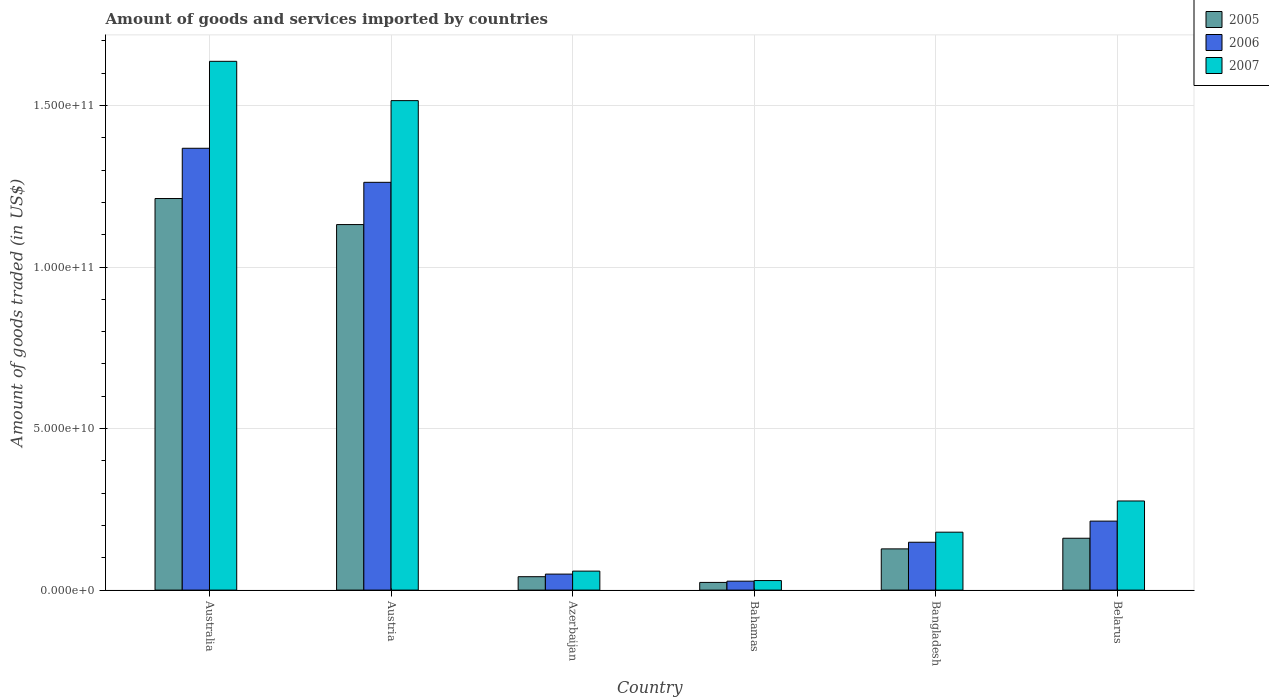How many different coloured bars are there?
Your answer should be compact. 3. How many bars are there on the 6th tick from the left?
Your answer should be compact. 3. How many bars are there on the 4th tick from the right?
Your answer should be compact. 3. What is the label of the 6th group of bars from the left?
Offer a terse response. Belarus. What is the total amount of goods and services imported in 2007 in Belarus?
Provide a succinct answer. 2.76e+1. Across all countries, what is the maximum total amount of goods and services imported in 2007?
Provide a succinct answer. 1.64e+11. Across all countries, what is the minimum total amount of goods and services imported in 2005?
Provide a succinct answer. 2.38e+09. In which country was the total amount of goods and services imported in 2005 maximum?
Offer a terse response. Australia. In which country was the total amount of goods and services imported in 2006 minimum?
Offer a very short reply. Bahamas. What is the total total amount of goods and services imported in 2005 in the graph?
Your answer should be very brief. 2.70e+11. What is the difference between the total amount of goods and services imported in 2006 in Austria and that in Azerbaijan?
Your answer should be very brief. 1.21e+11. What is the difference between the total amount of goods and services imported in 2006 in Bangladesh and the total amount of goods and services imported in 2007 in Austria?
Provide a short and direct response. -1.37e+11. What is the average total amount of goods and services imported in 2006 per country?
Provide a short and direct response. 5.11e+1. What is the difference between the total amount of goods and services imported of/in 2006 and total amount of goods and services imported of/in 2005 in Belarus?
Provide a succinct answer. 5.30e+09. What is the ratio of the total amount of goods and services imported in 2007 in Bahamas to that in Belarus?
Provide a succinct answer. 0.11. Is the difference between the total amount of goods and services imported in 2006 in Austria and Bahamas greater than the difference between the total amount of goods and services imported in 2005 in Austria and Bahamas?
Offer a very short reply. Yes. What is the difference between the highest and the second highest total amount of goods and services imported in 2006?
Keep it short and to the point. 1.05e+1. What is the difference between the highest and the lowest total amount of goods and services imported in 2006?
Your answer should be very brief. 1.34e+11. Is the sum of the total amount of goods and services imported in 2006 in Australia and Azerbaijan greater than the maximum total amount of goods and services imported in 2007 across all countries?
Provide a succinct answer. No. What does the 1st bar from the left in Bahamas represents?
Provide a succinct answer. 2005. What does the 3rd bar from the right in Belarus represents?
Provide a short and direct response. 2005. Is it the case that in every country, the sum of the total amount of goods and services imported in 2007 and total amount of goods and services imported in 2006 is greater than the total amount of goods and services imported in 2005?
Provide a succinct answer. Yes. How many bars are there?
Offer a terse response. 18. Are all the bars in the graph horizontal?
Give a very brief answer. No. Does the graph contain any zero values?
Give a very brief answer. No. Does the graph contain grids?
Ensure brevity in your answer.  Yes. Where does the legend appear in the graph?
Your response must be concise. Top right. How are the legend labels stacked?
Your answer should be very brief. Vertical. What is the title of the graph?
Your answer should be very brief. Amount of goods and services imported by countries. Does "2008" appear as one of the legend labels in the graph?
Offer a very short reply. No. What is the label or title of the X-axis?
Your response must be concise. Country. What is the label or title of the Y-axis?
Give a very brief answer. Amount of goods traded (in US$). What is the Amount of goods traded (in US$) of 2005 in Australia?
Offer a very short reply. 1.21e+11. What is the Amount of goods traded (in US$) in 2006 in Australia?
Your answer should be compact. 1.37e+11. What is the Amount of goods traded (in US$) in 2007 in Australia?
Ensure brevity in your answer.  1.64e+11. What is the Amount of goods traded (in US$) of 2005 in Austria?
Provide a short and direct response. 1.13e+11. What is the Amount of goods traded (in US$) in 2006 in Austria?
Offer a terse response. 1.26e+11. What is the Amount of goods traded (in US$) of 2007 in Austria?
Ensure brevity in your answer.  1.52e+11. What is the Amount of goods traded (in US$) in 2005 in Azerbaijan?
Offer a very short reply. 4.15e+09. What is the Amount of goods traded (in US$) of 2006 in Azerbaijan?
Your answer should be very brief. 4.95e+09. What is the Amount of goods traded (in US$) of 2007 in Azerbaijan?
Provide a short and direct response. 5.88e+09. What is the Amount of goods traded (in US$) in 2005 in Bahamas?
Make the answer very short. 2.38e+09. What is the Amount of goods traded (in US$) in 2006 in Bahamas?
Provide a short and direct response. 2.77e+09. What is the Amount of goods traded (in US$) of 2007 in Bahamas?
Your response must be concise. 2.96e+09. What is the Amount of goods traded (in US$) of 2005 in Bangladesh?
Ensure brevity in your answer.  1.28e+1. What is the Amount of goods traded (in US$) in 2006 in Bangladesh?
Provide a succinct answer. 1.48e+1. What is the Amount of goods traded (in US$) of 2007 in Bangladesh?
Provide a succinct answer. 1.79e+1. What is the Amount of goods traded (in US$) of 2005 in Belarus?
Provide a short and direct response. 1.61e+1. What is the Amount of goods traded (in US$) in 2006 in Belarus?
Keep it short and to the point. 2.14e+1. What is the Amount of goods traded (in US$) of 2007 in Belarus?
Provide a short and direct response. 2.76e+1. Across all countries, what is the maximum Amount of goods traded (in US$) of 2005?
Provide a short and direct response. 1.21e+11. Across all countries, what is the maximum Amount of goods traded (in US$) in 2006?
Provide a short and direct response. 1.37e+11. Across all countries, what is the maximum Amount of goods traded (in US$) of 2007?
Your response must be concise. 1.64e+11. Across all countries, what is the minimum Amount of goods traded (in US$) in 2005?
Provide a succinct answer. 2.38e+09. Across all countries, what is the minimum Amount of goods traded (in US$) in 2006?
Offer a very short reply. 2.77e+09. Across all countries, what is the minimum Amount of goods traded (in US$) of 2007?
Give a very brief answer. 2.96e+09. What is the total Amount of goods traded (in US$) in 2005 in the graph?
Give a very brief answer. 2.70e+11. What is the total Amount of goods traded (in US$) in 2006 in the graph?
Your answer should be compact. 3.07e+11. What is the total Amount of goods traded (in US$) of 2007 in the graph?
Offer a terse response. 3.70e+11. What is the difference between the Amount of goods traded (in US$) in 2005 in Australia and that in Austria?
Offer a very short reply. 8.06e+09. What is the difference between the Amount of goods traded (in US$) of 2006 in Australia and that in Austria?
Your answer should be compact. 1.05e+1. What is the difference between the Amount of goods traded (in US$) of 2007 in Australia and that in Austria?
Provide a short and direct response. 1.22e+1. What is the difference between the Amount of goods traded (in US$) in 2005 in Australia and that in Azerbaijan?
Your response must be concise. 1.17e+11. What is the difference between the Amount of goods traded (in US$) in 2006 in Australia and that in Azerbaijan?
Provide a succinct answer. 1.32e+11. What is the difference between the Amount of goods traded (in US$) in 2007 in Australia and that in Azerbaijan?
Offer a very short reply. 1.58e+11. What is the difference between the Amount of goods traded (in US$) of 2005 in Australia and that in Bahamas?
Offer a terse response. 1.19e+11. What is the difference between the Amount of goods traded (in US$) in 2006 in Australia and that in Bahamas?
Offer a terse response. 1.34e+11. What is the difference between the Amount of goods traded (in US$) of 2007 in Australia and that in Bahamas?
Provide a succinct answer. 1.61e+11. What is the difference between the Amount of goods traded (in US$) of 2005 in Australia and that in Bangladesh?
Your answer should be compact. 1.08e+11. What is the difference between the Amount of goods traded (in US$) of 2006 in Australia and that in Bangladesh?
Keep it short and to the point. 1.22e+11. What is the difference between the Amount of goods traded (in US$) of 2007 in Australia and that in Bangladesh?
Make the answer very short. 1.46e+11. What is the difference between the Amount of goods traded (in US$) in 2005 in Australia and that in Belarus?
Your answer should be compact. 1.05e+11. What is the difference between the Amount of goods traded (in US$) of 2006 in Australia and that in Belarus?
Make the answer very short. 1.15e+11. What is the difference between the Amount of goods traded (in US$) of 2007 in Australia and that in Belarus?
Ensure brevity in your answer.  1.36e+11. What is the difference between the Amount of goods traded (in US$) of 2005 in Austria and that in Azerbaijan?
Ensure brevity in your answer.  1.09e+11. What is the difference between the Amount of goods traded (in US$) of 2006 in Austria and that in Azerbaijan?
Offer a very short reply. 1.21e+11. What is the difference between the Amount of goods traded (in US$) in 2007 in Austria and that in Azerbaijan?
Give a very brief answer. 1.46e+11. What is the difference between the Amount of goods traded (in US$) of 2005 in Austria and that in Bahamas?
Keep it short and to the point. 1.11e+11. What is the difference between the Amount of goods traded (in US$) in 2006 in Austria and that in Bahamas?
Provide a short and direct response. 1.23e+11. What is the difference between the Amount of goods traded (in US$) in 2007 in Austria and that in Bahamas?
Offer a terse response. 1.49e+11. What is the difference between the Amount of goods traded (in US$) of 2005 in Austria and that in Bangladesh?
Give a very brief answer. 1.00e+11. What is the difference between the Amount of goods traded (in US$) in 2006 in Austria and that in Bangladesh?
Offer a very short reply. 1.11e+11. What is the difference between the Amount of goods traded (in US$) of 2007 in Austria and that in Bangladesh?
Give a very brief answer. 1.34e+11. What is the difference between the Amount of goods traded (in US$) in 2005 in Austria and that in Belarus?
Keep it short and to the point. 9.71e+1. What is the difference between the Amount of goods traded (in US$) of 2006 in Austria and that in Belarus?
Provide a short and direct response. 1.05e+11. What is the difference between the Amount of goods traded (in US$) in 2007 in Austria and that in Belarus?
Make the answer very short. 1.24e+11. What is the difference between the Amount of goods traded (in US$) of 2005 in Azerbaijan and that in Bahamas?
Keep it short and to the point. 1.77e+09. What is the difference between the Amount of goods traded (in US$) of 2006 in Azerbaijan and that in Bahamas?
Your response must be concise. 2.19e+09. What is the difference between the Amount of goods traded (in US$) in 2007 in Azerbaijan and that in Bahamas?
Provide a succinct answer. 2.92e+09. What is the difference between the Amount of goods traded (in US$) in 2005 in Azerbaijan and that in Bangladesh?
Your response must be concise. -8.61e+09. What is the difference between the Amount of goods traded (in US$) of 2006 in Azerbaijan and that in Bangladesh?
Your answer should be compact. -9.86e+09. What is the difference between the Amount of goods traded (in US$) in 2007 in Azerbaijan and that in Bangladesh?
Provide a succinct answer. -1.20e+1. What is the difference between the Amount of goods traded (in US$) in 2005 in Azerbaijan and that in Belarus?
Make the answer very short. -1.19e+1. What is the difference between the Amount of goods traded (in US$) in 2006 in Azerbaijan and that in Belarus?
Offer a terse response. -1.64e+1. What is the difference between the Amount of goods traded (in US$) in 2007 in Azerbaijan and that in Belarus?
Your response must be concise. -2.17e+1. What is the difference between the Amount of goods traded (in US$) in 2005 in Bahamas and that in Bangladesh?
Give a very brief answer. -1.04e+1. What is the difference between the Amount of goods traded (in US$) in 2006 in Bahamas and that in Bangladesh?
Provide a succinct answer. -1.20e+1. What is the difference between the Amount of goods traded (in US$) in 2007 in Bahamas and that in Bangladesh?
Provide a succinct answer. -1.50e+1. What is the difference between the Amount of goods traded (in US$) of 2005 in Bahamas and that in Belarus?
Provide a short and direct response. -1.37e+1. What is the difference between the Amount of goods traded (in US$) of 2006 in Bahamas and that in Belarus?
Your response must be concise. -1.86e+1. What is the difference between the Amount of goods traded (in US$) in 2007 in Bahamas and that in Belarus?
Ensure brevity in your answer.  -2.46e+1. What is the difference between the Amount of goods traded (in US$) in 2005 in Bangladesh and that in Belarus?
Offer a very short reply. -3.30e+09. What is the difference between the Amount of goods traded (in US$) of 2006 in Bangladesh and that in Belarus?
Offer a terse response. -6.54e+09. What is the difference between the Amount of goods traded (in US$) in 2007 in Bangladesh and that in Belarus?
Offer a very short reply. -9.66e+09. What is the difference between the Amount of goods traded (in US$) of 2005 in Australia and the Amount of goods traded (in US$) of 2006 in Austria?
Keep it short and to the point. -5.01e+09. What is the difference between the Amount of goods traded (in US$) of 2005 in Australia and the Amount of goods traded (in US$) of 2007 in Austria?
Offer a very short reply. -3.03e+1. What is the difference between the Amount of goods traded (in US$) in 2006 in Australia and the Amount of goods traded (in US$) in 2007 in Austria?
Your response must be concise. -1.47e+1. What is the difference between the Amount of goods traded (in US$) of 2005 in Australia and the Amount of goods traded (in US$) of 2006 in Azerbaijan?
Ensure brevity in your answer.  1.16e+11. What is the difference between the Amount of goods traded (in US$) in 2005 in Australia and the Amount of goods traded (in US$) in 2007 in Azerbaijan?
Offer a terse response. 1.15e+11. What is the difference between the Amount of goods traded (in US$) in 2006 in Australia and the Amount of goods traded (in US$) in 2007 in Azerbaijan?
Make the answer very short. 1.31e+11. What is the difference between the Amount of goods traded (in US$) in 2005 in Australia and the Amount of goods traded (in US$) in 2006 in Bahamas?
Your answer should be compact. 1.18e+11. What is the difference between the Amount of goods traded (in US$) of 2005 in Australia and the Amount of goods traded (in US$) of 2007 in Bahamas?
Offer a terse response. 1.18e+11. What is the difference between the Amount of goods traded (in US$) in 2006 in Australia and the Amount of goods traded (in US$) in 2007 in Bahamas?
Give a very brief answer. 1.34e+11. What is the difference between the Amount of goods traded (in US$) in 2005 in Australia and the Amount of goods traded (in US$) in 2006 in Bangladesh?
Ensure brevity in your answer.  1.06e+11. What is the difference between the Amount of goods traded (in US$) of 2005 in Australia and the Amount of goods traded (in US$) of 2007 in Bangladesh?
Offer a terse response. 1.03e+11. What is the difference between the Amount of goods traded (in US$) of 2006 in Australia and the Amount of goods traded (in US$) of 2007 in Bangladesh?
Your answer should be very brief. 1.19e+11. What is the difference between the Amount of goods traded (in US$) of 2005 in Australia and the Amount of goods traded (in US$) of 2006 in Belarus?
Make the answer very short. 9.99e+1. What is the difference between the Amount of goods traded (in US$) of 2005 in Australia and the Amount of goods traded (in US$) of 2007 in Belarus?
Your answer should be very brief. 9.36e+1. What is the difference between the Amount of goods traded (in US$) in 2006 in Australia and the Amount of goods traded (in US$) in 2007 in Belarus?
Provide a short and direct response. 1.09e+11. What is the difference between the Amount of goods traded (in US$) of 2005 in Austria and the Amount of goods traded (in US$) of 2006 in Azerbaijan?
Provide a short and direct response. 1.08e+11. What is the difference between the Amount of goods traded (in US$) in 2005 in Austria and the Amount of goods traded (in US$) in 2007 in Azerbaijan?
Offer a very short reply. 1.07e+11. What is the difference between the Amount of goods traded (in US$) of 2006 in Austria and the Amount of goods traded (in US$) of 2007 in Azerbaijan?
Ensure brevity in your answer.  1.20e+11. What is the difference between the Amount of goods traded (in US$) of 2005 in Austria and the Amount of goods traded (in US$) of 2006 in Bahamas?
Provide a succinct answer. 1.10e+11. What is the difference between the Amount of goods traded (in US$) of 2005 in Austria and the Amount of goods traded (in US$) of 2007 in Bahamas?
Your response must be concise. 1.10e+11. What is the difference between the Amount of goods traded (in US$) of 2006 in Austria and the Amount of goods traded (in US$) of 2007 in Bahamas?
Ensure brevity in your answer.  1.23e+11. What is the difference between the Amount of goods traded (in US$) of 2005 in Austria and the Amount of goods traded (in US$) of 2006 in Bangladesh?
Your answer should be very brief. 9.83e+1. What is the difference between the Amount of goods traded (in US$) in 2005 in Austria and the Amount of goods traded (in US$) in 2007 in Bangladesh?
Your response must be concise. 9.52e+1. What is the difference between the Amount of goods traded (in US$) in 2006 in Austria and the Amount of goods traded (in US$) in 2007 in Bangladesh?
Give a very brief answer. 1.08e+11. What is the difference between the Amount of goods traded (in US$) in 2005 in Austria and the Amount of goods traded (in US$) in 2006 in Belarus?
Your answer should be compact. 9.18e+1. What is the difference between the Amount of goods traded (in US$) of 2005 in Austria and the Amount of goods traded (in US$) of 2007 in Belarus?
Provide a short and direct response. 8.56e+1. What is the difference between the Amount of goods traded (in US$) of 2006 in Austria and the Amount of goods traded (in US$) of 2007 in Belarus?
Offer a terse response. 9.86e+1. What is the difference between the Amount of goods traded (in US$) of 2005 in Azerbaijan and the Amount of goods traded (in US$) of 2006 in Bahamas?
Offer a very short reply. 1.39e+09. What is the difference between the Amount of goods traded (in US$) in 2005 in Azerbaijan and the Amount of goods traded (in US$) in 2007 in Bahamas?
Ensure brevity in your answer.  1.19e+09. What is the difference between the Amount of goods traded (in US$) of 2006 in Azerbaijan and the Amount of goods traded (in US$) of 2007 in Bahamas?
Your answer should be compact. 2.00e+09. What is the difference between the Amount of goods traded (in US$) of 2005 in Azerbaijan and the Amount of goods traded (in US$) of 2006 in Bangladesh?
Your answer should be compact. -1.07e+1. What is the difference between the Amount of goods traded (in US$) in 2005 in Azerbaijan and the Amount of goods traded (in US$) in 2007 in Bangladesh?
Offer a terse response. -1.38e+1. What is the difference between the Amount of goods traded (in US$) in 2006 in Azerbaijan and the Amount of goods traded (in US$) in 2007 in Bangladesh?
Your answer should be very brief. -1.30e+1. What is the difference between the Amount of goods traded (in US$) in 2005 in Azerbaijan and the Amount of goods traded (in US$) in 2006 in Belarus?
Provide a succinct answer. -1.72e+1. What is the difference between the Amount of goods traded (in US$) of 2005 in Azerbaijan and the Amount of goods traded (in US$) of 2007 in Belarus?
Provide a short and direct response. -2.34e+1. What is the difference between the Amount of goods traded (in US$) in 2006 in Azerbaijan and the Amount of goods traded (in US$) in 2007 in Belarus?
Your answer should be very brief. -2.26e+1. What is the difference between the Amount of goods traded (in US$) in 2005 in Bahamas and the Amount of goods traded (in US$) in 2006 in Bangladesh?
Make the answer very short. -1.24e+1. What is the difference between the Amount of goods traded (in US$) of 2005 in Bahamas and the Amount of goods traded (in US$) of 2007 in Bangladesh?
Provide a succinct answer. -1.55e+1. What is the difference between the Amount of goods traded (in US$) of 2006 in Bahamas and the Amount of goods traded (in US$) of 2007 in Bangladesh?
Give a very brief answer. -1.52e+1. What is the difference between the Amount of goods traded (in US$) in 2005 in Bahamas and the Amount of goods traded (in US$) in 2006 in Belarus?
Ensure brevity in your answer.  -1.90e+1. What is the difference between the Amount of goods traded (in US$) of 2005 in Bahamas and the Amount of goods traded (in US$) of 2007 in Belarus?
Your answer should be very brief. -2.52e+1. What is the difference between the Amount of goods traded (in US$) in 2006 in Bahamas and the Amount of goods traded (in US$) in 2007 in Belarus?
Your answer should be compact. -2.48e+1. What is the difference between the Amount of goods traded (in US$) of 2005 in Bangladesh and the Amount of goods traded (in US$) of 2006 in Belarus?
Keep it short and to the point. -8.59e+09. What is the difference between the Amount of goods traded (in US$) of 2005 in Bangladesh and the Amount of goods traded (in US$) of 2007 in Belarus?
Make the answer very short. -1.48e+1. What is the difference between the Amount of goods traded (in US$) in 2006 in Bangladesh and the Amount of goods traded (in US$) in 2007 in Belarus?
Your response must be concise. -1.28e+1. What is the average Amount of goods traded (in US$) in 2005 per country?
Keep it short and to the point. 4.49e+1. What is the average Amount of goods traded (in US$) of 2006 per country?
Give a very brief answer. 5.11e+1. What is the average Amount of goods traded (in US$) of 2007 per country?
Offer a terse response. 6.16e+1. What is the difference between the Amount of goods traded (in US$) in 2005 and Amount of goods traded (in US$) in 2006 in Australia?
Ensure brevity in your answer.  -1.56e+1. What is the difference between the Amount of goods traded (in US$) in 2005 and Amount of goods traded (in US$) in 2007 in Australia?
Your answer should be compact. -4.25e+1. What is the difference between the Amount of goods traded (in US$) in 2006 and Amount of goods traded (in US$) in 2007 in Australia?
Provide a short and direct response. -2.69e+1. What is the difference between the Amount of goods traded (in US$) of 2005 and Amount of goods traded (in US$) of 2006 in Austria?
Offer a terse response. -1.31e+1. What is the difference between the Amount of goods traded (in US$) of 2005 and Amount of goods traded (in US$) of 2007 in Austria?
Offer a terse response. -3.84e+1. What is the difference between the Amount of goods traded (in US$) in 2006 and Amount of goods traded (in US$) in 2007 in Austria?
Make the answer very short. -2.53e+1. What is the difference between the Amount of goods traded (in US$) of 2005 and Amount of goods traded (in US$) of 2006 in Azerbaijan?
Your answer should be compact. -8.02e+08. What is the difference between the Amount of goods traded (in US$) in 2005 and Amount of goods traded (in US$) in 2007 in Azerbaijan?
Give a very brief answer. -1.73e+09. What is the difference between the Amount of goods traded (in US$) in 2006 and Amount of goods traded (in US$) in 2007 in Azerbaijan?
Offer a very short reply. -9.23e+08. What is the difference between the Amount of goods traded (in US$) in 2005 and Amount of goods traded (in US$) in 2006 in Bahamas?
Keep it short and to the point. -3.89e+08. What is the difference between the Amount of goods traded (in US$) in 2005 and Amount of goods traded (in US$) in 2007 in Bahamas?
Your answer should be compact. -5.79e+08. What is the difference between the Amount of goods traded (in US$) in 2006 and Amount of goods traded (in US$) in 2007 in Bahamas?
Your response must be concise. -1.90e+08. What is the difference between the Amount of goods traded (in US$) in 2005 and Amount of goods traded (in US$) in 2006 in Bangladesh?
Give a very brief answer. -2.06e+09. What is the difference between the Amount of goods traded (in US$) in 2005 and Amount of goods traded (in US$) in 2007 in Bangladesh?
Provide a short and direct response. -5.17e+09. What is the difference between the Amount of goods traded (in US$) in 2006 and Amount of goods traded (in US$) in 2007 in Bangladesh?
Give a very brief answer. -3.11e+09. What is the difference between the Amount of goods traded (in US$) in 2005 and Amount of goods traded (in US$) in 2006 in Belarus?
Your answer should be compact. -5.30e+09. What is the difference between the Amount of goods traded (in US$) in 2005 and Amount of goods traded (in US$) in 2007 in Belarus?
Your response must be concise. -1.15e+1. What is the difference between the Amount of goods traded (in US$) in 2006 and Amount of goods traded (in US$) in 2007 in Belarus?
Offer a very short reply. -6.23e+09. What is the ratio of the Amount of goods traded (in US$) of 2005 in Australia to that in Austria?
Your answer should be compact. 1.07. What is the ratio of the Amount of goods traded (in US$) in 2006 in Australia to that in Austria?
Your response must be concise. 1.08. What is the ratio of the Amount of goods traded (in US$) in 2007 in Australia to that in Austria?
Your answer should be compact. 1.08. What is the ratio of the Amount of goods traded (in US$) in 2005 in Australia to that in Azerbaijan?
Provide a succinct answer. 29.19. What is the ratio of the Amount of goods traded (in US$) in 2006 in Australia to that in Azerbaijan?
Provide a succinct answer. 27.61. What is the ratio of the Amount of goods traded (in US$) in 2007 in Australia to that in Azerbaijan?
Keep it short and to the point. 27.85. What is the ratio of the Amount of goods traded (in US$) of 2005 in Australia to that in Bahamas?
Offer a very short reply. 50.98. What is the ratio of the Amount of goods traded (in US$) in 2006 in Australia to that in Bahamas?
Your answer should be compact. 49.43. What is the ratio of the Amount of goods traded (in US$) of 2007 in Australia to that in Bahamas?
Your answer should be compact. 55.35. What is the ratio of the Amount of goods traded (in US$) of 2005 in Australia to that in Bangladesh?
Give a very brief answer. 9.5. What is the ratio of the Amount of goods traded (in US$) of 2006 in Australia to that in Bangladesh?
Provide a short and direct response. 9.23. What is the ratio of the Amount of goods traded (in US$) of 2007 in Australia to that in Bangladesh?
Your answer should be very brief. 9.13. What is the ratio of the Amount of goods traded (in US$) in 2005 in Australia to that in Belarus?
Keep it short and to the point. 7.55. What is the ratio of the Amount of goods traded (in US$) of 2006 in Australia to that in Belarus?
Provide a short and direct response. 6.41. What is the ratio of the Amount of goods traded (in US$) in 2007 in Australia to that in Belarus?
Ensure brevity in your answer.  5.93. What is the ratio of the Amount of goods traded (in US$) in 2005 in Austria to that in Azerbaijan?
Your answer should be very brief. 27.25. What is the ratio of the Amount of goods traded (in US$) of 2006 in Austria to that in Azerbaijan?
Your answer should be compact. 25.48. What is the ratio of the Amount of goods traded (in US$) in 2007 in Austria to that in Azerbaijan?
Keep it short and to the point. 25.78. What is the ratio of the Amount of goods traded (in US$) in 2005 in Austria to that in Bahamas?
Give a very brief answer. 47.59. What is the ratio of the Amount of goods traded (in US$) of 2006 in Austria to that in Bahamas?
Offer a terse response. 45.62. What is the ratio of the Amount of goods traded (in US$) of 2007 in Austria to that in Bahamas?
Provide a short and direct response. 51.24. What is the ratio of the Amount of goods traded (in US$) in 2005 in Austria to that in Bangladesh?
Offer a terse response. 8.87. What is the ratio of the Amount of goods traded (in US$) of 2006 in Austria to that in Bangladesh?
Offer a very short reply. 8.52. What is the ratio of the Amount of goods traded (in US$) of 2007 in Austria to that in Bangladesh?
Your answer should be compact. 8.45. What is the ratio of the Amount of goods traded (in US$) of 2005 in Austria to that in Belarus?
Keep it short and to the point. 7.05. What is the ratio of the Amount of goods traded (in US$) of 2006 in Austria to that in Belarus?
Offer a very short reply. 5.91. What is the ratio of the Amount of goods traded (in US$) in 2007 in Austria to that in Belarus?
Keep it short and to the point. 5.49. What is the ratio of the Amount of goods traded (in US$) of 2005 in Azerbaijan to that in Bahamas?
Your answer should be compact. 1.75. What is the ratio of the Amount of goods traded (in US$) in 2006 in Azerbaijan to that in Bahamas?
Your response must be concise. 1.79. What is the ratio of the Amount of goods traded (in US$) of 2007 in Azerbaijan to that in Bahamas?
Offer a terse response. 1.99. What is the ratio of the Amount of goods traded (in US$) in 2005 in Azerbaijan to that in Bangladesh?
Offer a terse response. 0.33. What is the ratio of the Amount of goods traded (in US$) of 2006 in Azerbaijan to that in Bangladesh?
Keep it short and to the point. 0.33. What is the ratio of the Amount of goods traded (in US$) of 2007 in Azerbaijan to that in Bangladesh?
Offer a terse response. 0.33. What is the ratio of the Amount of goods traded (in US$) in 2005 in Azerbaijan to that in Belarus?
Provide a short and direct response. 0.26. What is the ratio of the Amount of goods traded (in US$) in 2006 in Azerbaijan to that in Belarus?
Your response must be concise. 0.23. What is the ratio of the Amount of goods traded (in US$) in 2007 in Azerbaijan to that in Belarus?
Give a very brief answer. 0.21. What is the ratio of the Amount of goods traded (in US$) in 2005 in Bahamas to that in Bangladesh?
Provide a short and direct response. 0.19. What is the ratio of the Amount of goods traded (in US$) of 2006 in Bahamas to that in Bangladesh?
Offer a terse response. 0.19. What is the ratio of the Amount of goods traded (in US$) in 2007 in Bahamas to that in Bangladesh?
Make the answer very short. 0.16. What is the ratio of the Amount of goods traded (in US$) in 2005 in Bahamas to that in Belarus?
Provide a succinct answer. 0.15. What is the ratio of the Amount of goods traded (in US$) in 2006 in Bahamas to that in Belarus?
Provide a succinct answer. 0.13. What is the ratio of the Amount of goods traded (in US$) of 2007 in Bahamas to that in Belarus?
Ensure brevity in your answer.  0.11. What is the ratio of the Amount of goods traded (in US$) of 2005 in Bangladesh to that in Belarus?
Ensure brevity in your answer.  0.79. What is the ratio of the Amount of goods traded (in US$) of 2006 in Bangladesh to that in Belarus?
Ensure brevity in your answer.  0.69. What is the ratio of the Amount of goods traded (in US$) in 2007 in Bangladesh to that in Belarus?
Make the answer very short. 0.65. What is the difference between the highest and the second highest Amount of goods traded (in US$) of 2005?
Your answer should be compact. 8.06e+09. What is the difference between the highest and the second highest Amount of goods traded (in US$) of 2006?
Your response must be concise. 1.05e+1. What is the difference between the highest and the second highest Amount of goods traded (in US$) of 2007?
Your response must be concise. 1.22e+1. What is the difference between the highest and the lowest Amount of goods traded (in US$) in 2005?
Your response must be concise. 1.19e+11. What is the difference between the highest and the lowest Amount of goods traded (in US$) in 2006?
Your answer should be compact. 1.34e+11. What is the difference between the highest and the lowest Amount of goods traded (in US$) in 2007?
Give a very brief answer. 1.61e+11. 